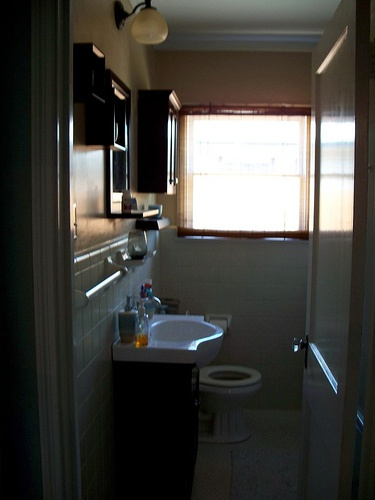Describe the objects in this image and their specific colors. I can see sink in black, gray, and lightblue tones, toilet in black tones, and bottle in black, gray, maroon, blue, and olive tones in this image. 